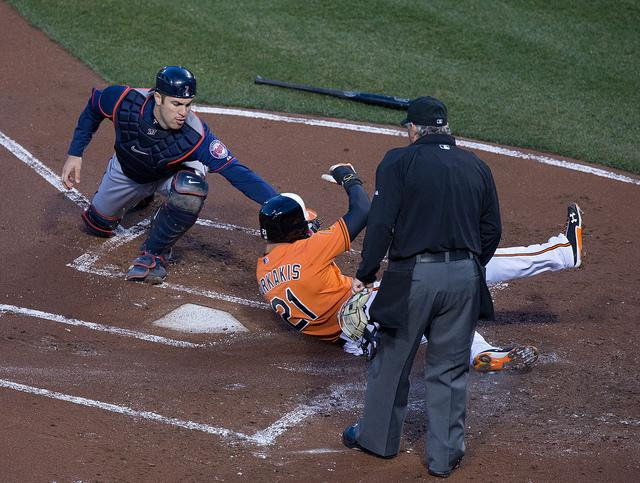What is the position of the man who is standing? Please explain your reasoning. umpire. He is an umpire. 